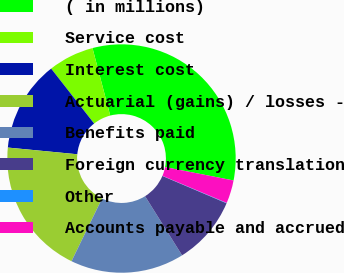Convert chart. <chart><loc_0><loc_0><loc_500><loc_500><pie_chart><fcel>( in millions)<fcel>Service cost<fcel>Interest cost<fcel>Actuarial (gains) / losses -<fcel>Benefits paid<fcel>Foreign currency translation<fcel>Other<fcel>Accounts payable and accrued<nl><fcel>32.16%<fcel>6.48%<fcel>12.9%<fcel>19.32%<fcel>16.11%<fcel>9.69%<fcel>0.06%<fcel>3.27%<nl></chart> 